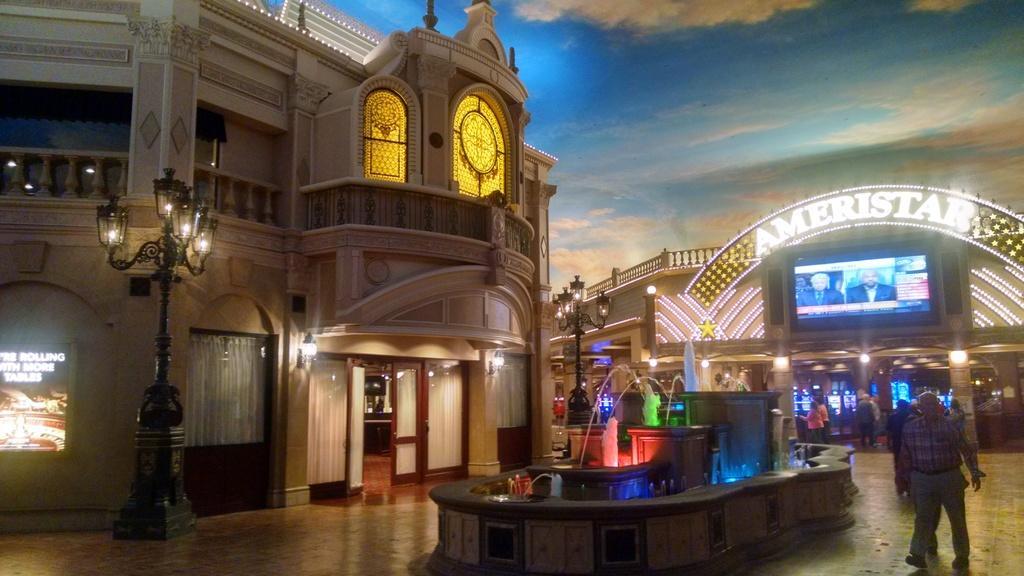Could you give a brief overview of what you see in this image? In this picture we can see a building, on the left side there is a pole and lights, on the right side there are some people walking, we can see a screen here, there is a water fountain in the middle, we can see the sky at the top of the picture. 